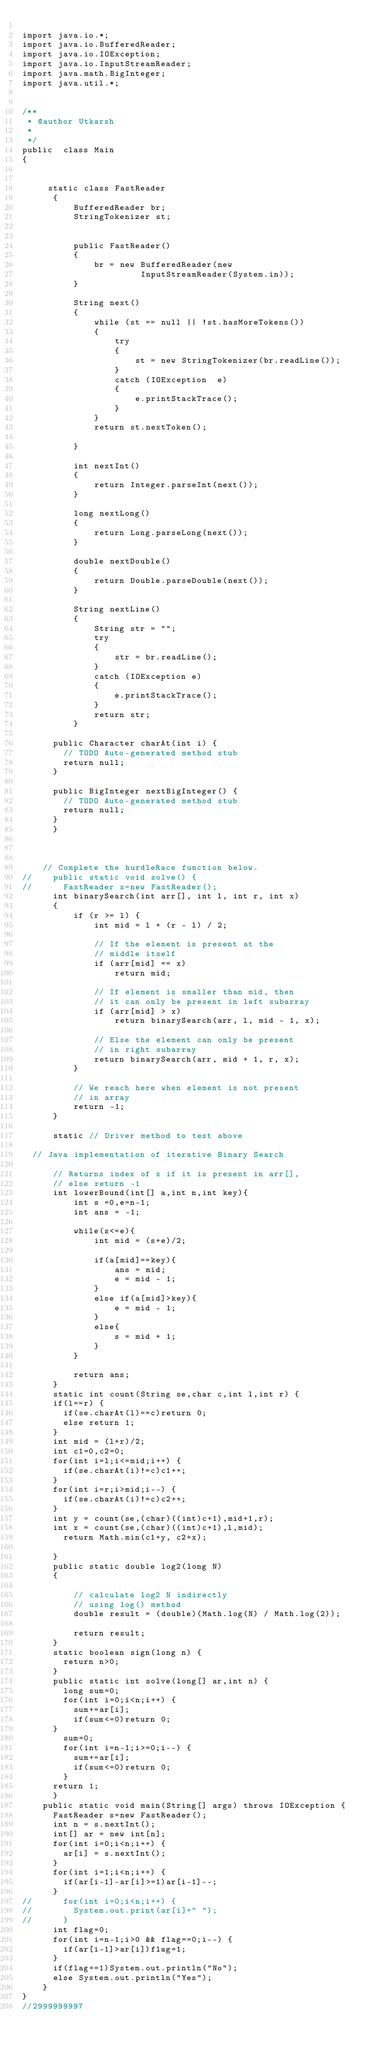Convert code to text. <code><loc_0><loc_0><loc_500><loc_500><_Java_>
import java.io.*;
import java.io.BufferedReader; 
import java.io.IOException; 
import java.io.InputStreamReader;
import java.math.BigInteger;
import java.util.*;


/**
 * @author Utkarsh
 *
 */
public  class Main 
{

	   
	   static class FastReader 
	    { 
	        BufferedReader br; 
	        StringTokenizer st; 
	       
	  
	        public FastReader() 
	        { 
	            br = new BufferedReader(new
	                     InputStreamReader(System.in)); 
	        } 
	  
	        String next() 
	        { 
	            while (st == null || !st.hasMoreTokens()) 
	            { 
	                try
	                { 
	                    st = new StringTokenizer(br.readLine()); 
	                } 
	                catch (IOException  e) 
	                { 
	                    e.printStackTrace(); 
	                } 
	            } 
	            return st.nextToken();
	            
	        } 
	  
	        int nextInt() 
	        { 
	            return Integer.parseInt(next()); 
	        } 
	  
	        long nextLong() 
	        { 
	            return Long.parseLong(next()); 
	        } 
	  
	        double nextDouble() 
	        { 
	            return Double.parseDouble(next()); 
	        } 
	  
	        String nextLine() 
	        { 
	            String str = ""; 
	            try
	            { 
	                str = br.readLine(); 
	            } 
	            catch (IOException e) 
	            { 
	                e.printStackTrace(); 
	            } 
	            return str; 
	        }

			public Character charAt(int i) {
				// TODO Auto-generated method stub
				return null;
			}

			public BigInteger nextBigInteger() {
				// TODO Auto-generated method stub
				return null;
			} 
	    } 

  

	  // Complete the hurdleRace function below.
//    public static void solve() {
//    	FastReader s=new FastReader();
	    int binarySearch(int arr[], int l, int r, int x) 
	    { 
	        if (r >= l) { 
	            int mid = l + (r - l) / 2; 
	  
	            // If the element is present at the 
	            // middle itself 
	            if (arr[mid] == x) 
	                return mid; 
	  
	            // If element is smaller than mid, then 
	            // it can only be present in left subarray 
	            if (arr[mid] > x) 
	                return binarySearch(arr, l, mid - 1, x); 
	  
	            // Else the element can only be present 
	            // in right subarray 
	            return binarySearch(arr, mid + 1, r, x); 
	        } 
	  
	        // We reach here when element is not present 
	        // in array 
	        return -1; 
	    } 
	  
	    static // Driver method to test above 

	// Java implementation of iterative Binary Search 

	    // Returns index of x if it is present in arr[], 
	    // else return -1 
	    int lowerBound(int[] a,int n,int key){
	        int s =0,e=n-1;
	        int ans = -1;

	        while(s<=e){
	            int mid = (s+e)/2;

	            if(a[mid]==key){
	                ans = mid;
	                e = mid - 1;
	            }
	            else if(a[mid]>key){
	                e = mid - 1;
	            }
	            else{
	                s = mid + 1;
	            }
	        }

	        return ans;
	    }
	    static int count(String se,char c,int l,int r) {
			if(l==r) {
				if(se.charAt(l)==c)return 0;
				else return 1;
			}
			int mid = (l+r)/2;
			int c1=0,c2=0;
			for(int i=l;i<=mid;i++) {
				if(se.charAt(i)!=c)c1++;
			}
			for(int i=r;i>mid;i--) {
				if(se.charAt(i)!=c)c2++;
			}
			int y = count(se,(char)((int)c+1),mid+1,r);
			int x = count(se,(char)((int)c+1),l,mid);
	    	return Math.min(c1+y, c2+x);
	    	
	    }
	    public static double log2(long N) 
	    { 
	  
	        // calculate log2 N indirectly 
	        // using log() method 
	        double result = (double)(Math.log(N) / Math.log(2)); 
	  
	        return result; 
	    }
	    static boolean sign(long n) {
	    	return n>0;
	    }
	    public static int solve(long[] ar,int n) {
	    	long sum=0;
	    	for(int i=0;i<n;i++) {
	    		sum+=ar[i];
	    		if(sum<=0)return 0;
			}
	    	sum=0;
	    	for(int i=n-1;i>=0;i--) {
	    		sum+=ar[i];
	    		if(sum<=0)return 0;
	    	}
			return 1;
	    }
    public static void main(String[] args) throws IOException {
    	FastReader s=new FastReader();
    	int n = s.nextInt();
    	int[] ar = new int[n];
    	for(int i=0;i<n;i++) {
    		ar[i] = s.nextInt();
    	}
    	for(int i=1;i<n;i++) {
    		if(ar[i-1]-ar[i]>=1)ar[i-1]--;
    	}
//    	for(int i=0;i<n;i++) {
//    		System.out.print(ar[i]+" ");
//    	}
    	int flag=0;
    	for(int i=n-1;i>0 && flag==0;i--) {
    		if(ar[i-1]>ar[i])flag=1;
    	}
    	if(flag==1)System.out.println("No"); 
    	else System.out.println("Yes");
    }	
}
//2999999997

        
    

      
 </code> 